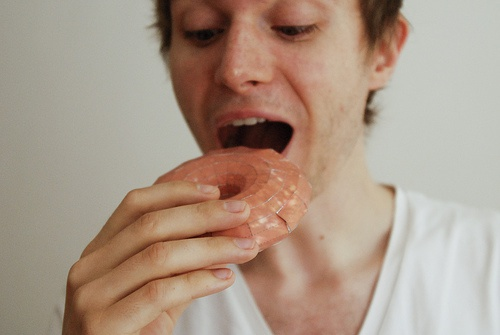Describe the objects in this image and their specific colors. I can see people in darkgray, salmon, tan, and lightgray tones and donut in darkgray, brown, and tan tones in this image. 